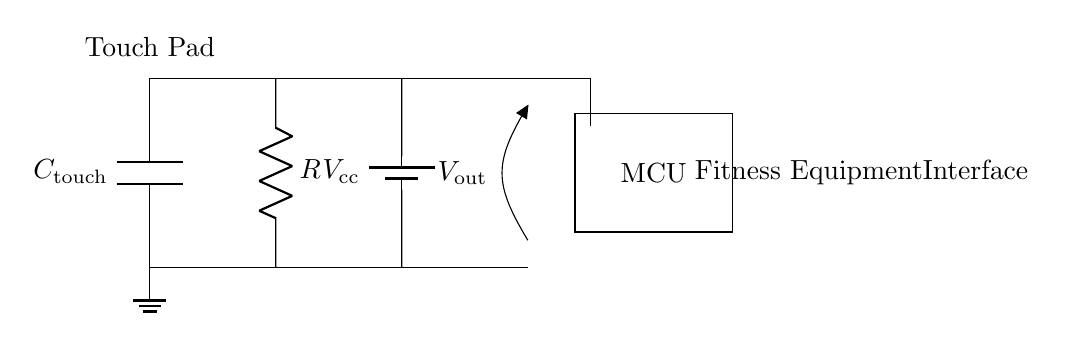What components are in the circuit? The circuit contains a capacitor, a resistor, a voltage source, and a microcontroller represented graphically. Each component is depicted in the diagram with respective labels.
Answer: capacitor, resistor, voltage source, microcontroller What is the purpose of the capacitor in this circuit? The capacitor acts as a touch sensor component that measures changes in capacitance when a finger touches the pad, allowing it to register user input. This is crucial in capacitive touch applications.
Answer: touch sensing What is the output voltage given the voltage source? The output voltage is the same as the voltage supplied by the source, which is typically expected to be five volts in such circuits unless otherwise indicated.
Answer: five volts Why is there a resistor in the circuit? The resistor is used to limit the current flowing through the capacitor, ensuring it does not exceed safe levels and preventing damage while enhancing sensitivity to touch.
Answer: current limiting What relation exists between resistance and capacitance in this circuit? The time constant of an RC circuit, which affects the response time of the touch sensor, is determined by the values of resistance and capacitance together. The time constant is calculated by multiplying resistance and capacitance.
Answer: RC time constant What kind of output does this circuit generate? The output voltage V_out is generated based on the capacitive touch input, which translates the touch into a signal that can be processed by the microcontroller for functionality.
Answer: touch signal 